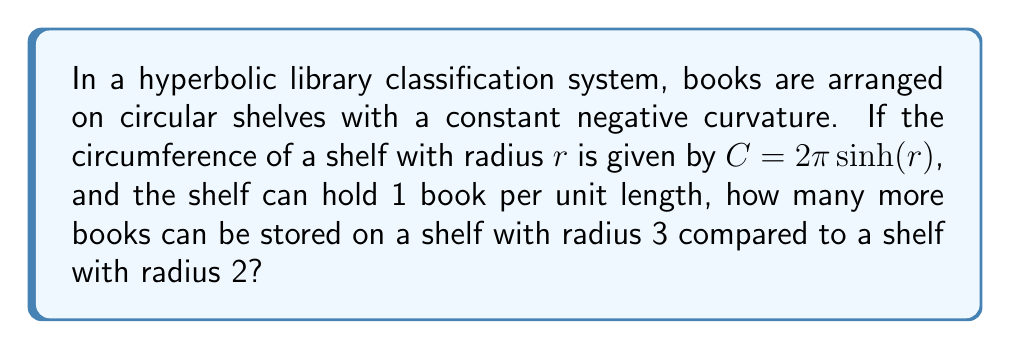Give your solution to this math problem. To solve this problem, we'll follow these steps:

1. Calculate the circumference of the shelf with radius 2:
   $$C_2 = 2\pi \sinh(2)$$
   $$C_2 = 2\pi \cdot 3.6268 \approx 22.7845$$

2. Calculate the circumference of the shelf with radius 3:
   $$C_3 = 2\pi \sinh(3)$$
   $$C_3 = 2\pi \cdot 10.0178 \approx 62.9351$$

3. Calculate the difference in circumference:
   $$\Delta C = C_3 - C_2 \approx 62.9351 - 22.7845 \approx 40.1506$$

4. Since each unit length can hold 1 book, the difference in circumference directly translates to the number of additional books that can be stored.

5. Round down to the nearest whole number, as we can't store partial books.

This problem demonstrates how hyperbolic geometry affects the organization of books in a library. The exponential growth in shelf space as the radius increases is a key feature of hyperbolic geometry, which could significantly impact the classification and arrangement of mathematical literature in such a system.
Answer: 40 books 